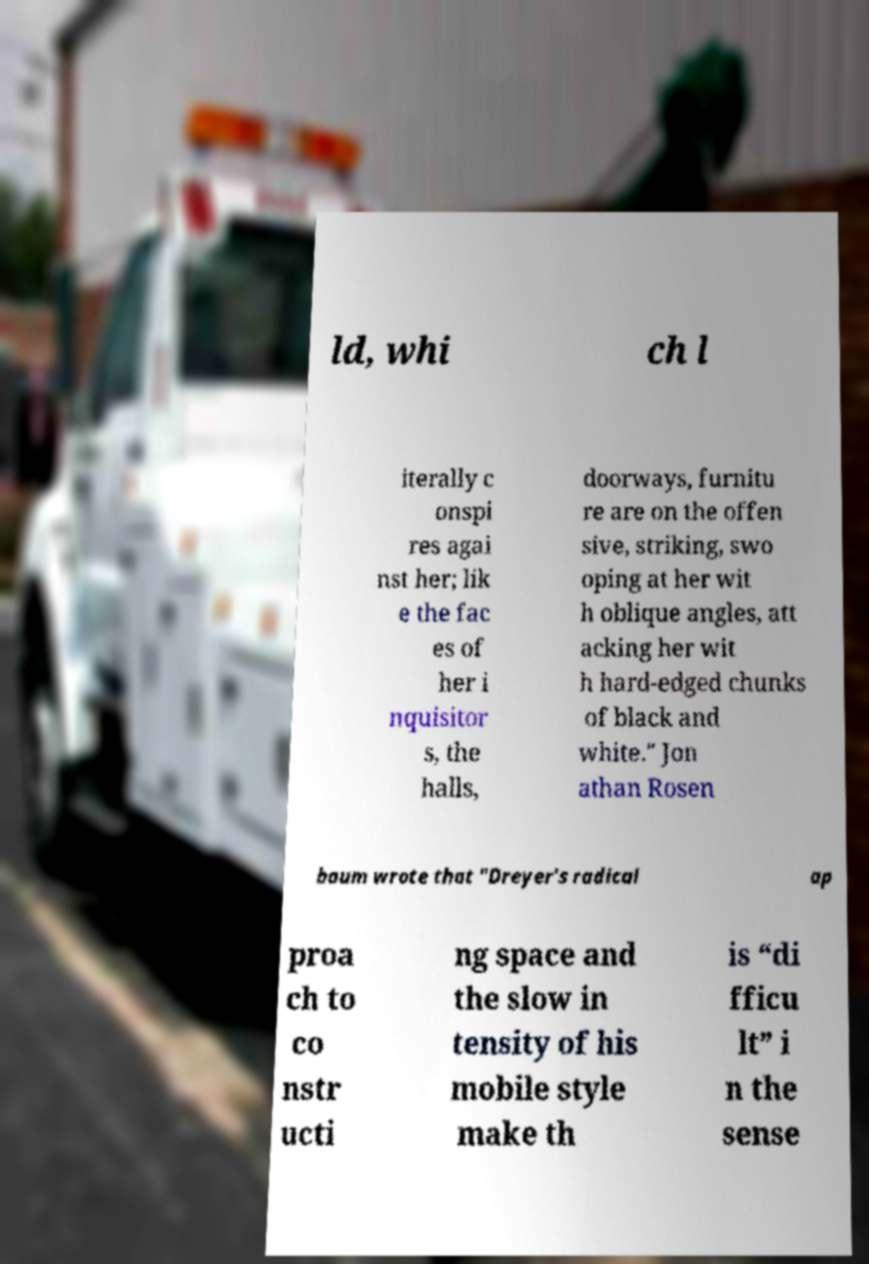For documentation purposes, I need the text within this image transcribed. Could you provide that? ld, whi ch l iterally c onspi res agai nst her; lik e the fac es of her i nquisitor s, the halls, doorways, furnitu re are on the offen sive, striking, swo oping at her wit h oblique angles, att acking her wit h hard-edged chunks of black and white." Jon athan Rosen baum wrote that "Dreyer's radical ap proa ch to co nstr ucti ng space and the slow in tensity of his mobile style make th is “di fficu lt” i n the sense 